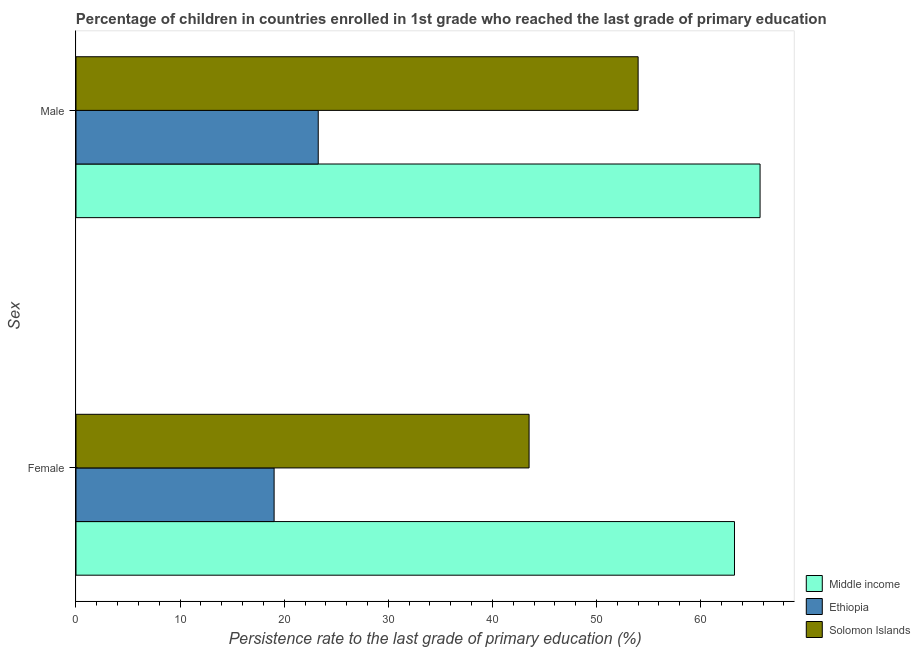How many groups of bars are there?
Give a very brief answer. 2. Are the number of bars per tick equal to the number of legend labels?
Offer a terse response. Yes. Are the number of bars on each tick of the Y-axis equal?
Your response must be concise. Yes. How many bars are there on the 2nd tick from the top?
Provide a succinct answer. 3. How many bars are there on the 2nd tick from the bottom?
Offer a very short reply. 3. What is the label of the 1st group of bars from the top?
Your answer should be very brief. Male. What is the persistence rate of male students in Solomon Islands?
Provide a short and direct response. 54. Across all countries, what is the maximum persistence rate of female students?
Your answer should be compact. 63.26. Across all countries, what is the minimum persistence rate of female students?
Your answer should be very brief. 19.03. In which country was the persistence rate of female students minimum?
Your answer should be very brief. Ethiopia. What is the total persistence rate of female students in the graph?
Give a very brief answer. 125.82. What is the difference between the persistence rate of female students in Ethiopia and that in Solomon Islands?
Ensure brevity in your answer.  -24.49. What is the difference between the persistence rate of male students in Solomon Islands and the persistence rate of female students in Ethiopia?
Give a very brief answer. 34.97. What is the average persistence rate of male students per country?
Keep it short and to the point. 47.66. What is the difference between the persistence rate of male students and persistence rate of female students in Solomon Islands?
Your answer should be compact. 10.47. What is the ratio of the persistence rate of female students in Middle income to that in Ethiopia?
Your answer should be compact. 3.32. Is the persistence rate of male students in Middle income less than that in Solomon Islands?
Make the answer very short. No. In how many countries, is the persistence rate of male students greater than the average persistence rate of male students taken over all countries?
Your answer should be compact. 2. What does the 1st bar from the top in Female represents?
Your answer should be very brief. Solomon Islands. What does the 2nd bar from the bottom in Female represents?
Offer a very short reply. Ethiopia. How many bars are there?
Provide a succinct answer. 6. How many countries are there in the graph?
Provide a short and direct response. 3. Are the values on the major ticks of X-axis written in scientific E-notation?
Make the answer very short. No. Does the graph contain any zero values?
Your answer should be very brief. No. Does the graph contain grids?
Give a very brief answer. No. Where does the legend appear in the graph?
Offer a terse response. Bottom right. How many legend labels are there?
Provide a succinct answer. 3. How are the legend labels stacked?
Your response must be concise. Vertical. What is the title of the graph?
Offer a terse response. Percentage of children in countries enrolled in 1st grade who reached the last grade of primary education. What is the label or title of the X-axis?
Make the answer very short. Persistence rate to the last grade of primary education (%). What is the label or title of the Y-axis?
Make the answer very short. Sex. What is the Persistence rate to the last grade of primary education (%) of Middle income in Female?
Make the answer very short. 63.26. What is the Persistence rate to the last grade of primary education (%) of Ethiopia in Female?
Ensure brevity in your answer.  19.03. What is the Persistence rate to the last grade of primary education (%) of Solomon Islands in Female?
Ensure brevity in your answer.  43.53. What is the Persistence rate to the last grade of primary education (%) in Middle income in Male?
Provide a short and direct response. 65.72. What is the Persistence rate to the last grade of primary education (%) of Ethiopia in Male?
Your answer should be compact. 23.27. What is the Persistence rate to the last grade of primary education (%) in Solomon Islands in Male?
Your answer should be very brief. 54. Across all Sex, what is the maximum Persistence rate to the last grade of primary education (%) of Middle income?
Your response must be concise. 65.72. Across all Sex, what is the maximum Persistence rate to the last grade of primary education (%) of Ethiopia?
Offer a terse response. 23.27. Across all Sex, what is the maximum Persistence rate to the last grade of primary education (%) in Solomon Islands?
Provide a succinct answer. 54. Across all Sex, what is the minimum Persistence rate to the last grade of primary education (%) in Middle income?
Offer a terse response. 63.26. Across all Sex, what is the minimum Persistence rate to the last grade of primary education (%) of Ethiopia?
Your answer should be compact. 19.03. Across all Sex, what is the minimum Persistence rate to the last grade of primary education (%) in Solomon Islands?
Offer a very short reply. 43.53. What is the total Persistence rate to the last grade of primary education (%) of Middle income in the graph?
Offer a very short reply. 128.98. What is the total Persistence rate to the last grade of primary education (%) of Ethiopia in the graph?
Keep it short and to the point. 42.3. What is the total Persistence rate to the last grade of primary education (%) in Solomon Islands in the graph?
Your answer should be compact. 97.53. What is the difference between the Persistence rate to the last grade of primary education (%) of Middle income in Female and that in Male?
Offer a very short reply. -2.46. What is the difference between the Persistence rate to the last grade of primary education (%) in Ethiopia in Female and that in Male?
Your answer should be compact. -4.24. What is the difference between the Persistence rate to the last grade of primary education (%) of Solomon Islands in Female and that in Male?
Your answer should be compact. -10.47. What is the difference between the Persistence rate to the last grade of primary education (%) in Middle income in Female and the Persistence rate to the last grade of primary education (%) in Ethiopia in Male?
Provide a succinct answer. 39.99. What is the difference between the Persistence rate to the last grade of primary education (%) in Middle income in Female and the Persistence rate to the last grade of primary education (%) in Solomon Islands in Male?
Ensure brevity in your answer.  9.26. What is the difference between the Persistence rate to the last grade of primary education (%) of Ethiopia in Female and the Persistence rate to the last grade of primary education (%) of Solomon Islands in Male?
Offer a terse response. -34.97. What is the average Persistence rate to the last grade of primary education (%) in Middle income per Sex?
Keep it short and to the point. 64.49. What is the average Persistence rate to the last grade of primary education (%) in Ethiopia per Sex?
Make the answer very short. 21.15. What is the average Persistence rate to the last grade of primary education (%) of Solomon Islands per Sex?
Offer a very short reply. 48.76. What is the difference between the Persistence rate to the last grade of primary education (%) of Middle income and Persistence rate to the last grade of primary education (%) of Ethiopia in Female?
Offer a terse response. 44.23. What is the difference between the Persistence rate to the last grade of primary education (%) of Middle income and Persistence rate to the last grade of primary education (%) of Solomon Islands in Female?
Your answer should be compact. 19.73. What is the difference between the Persistence rate to the last grade of primary education (%) of Ethiopia and Persistence rate to the last grade of primary education (%) of Solomon Islands in Female?
Your answer should be compact. -24.49. What is the difference between the Persistence rate to the last grade of primary education (%) of Middle income and Persistence rate to the last grade of primary education (%) of Ethiopia in Male?
Offer a very short reply. 42.44. What is the difference between the Persistence rate to the last grade of primary education (%) in Middle income and Persistence rate to the last grade of primary education (%) in Solomon Islands in Male?
Provide a succinct answer. 11.71. What is the difference between the Persistence rate to the last grade of primary education (%) in Ethiopia and Persistence rate to the last grade of primary education (%) in Solomon Islands in Male?
Your response must be concise. -30.73. What is the ratio of the Persistence rate to the last grade of primary education (%) of Middle income in Female to that in Male?
Your answer should be very brief. 0.96. What is the ratio of the Persistence rate to the last grade of primary education (%) of Ethiopia in Female to that in Male?
Your answer should be compact. 0.82. What is the ratio of the Persistence rate to the last grade of primary education (%) in Solomon Islands in Female to that in Male?
Offer a very short reply. 0.81. What is the difference between the highest and the second highest Persistence rate to the last grade of primary education (%) in Middle income?
Make the answer very short. 2.46. What is the difference between the highest and the second highest Persistence rate to the last grade of primary education (%) of Ethiopia?
Give a very brief answer. 4.24. What is the difference between the highest and the second highest Persistence rate to the last grade of primary education (%) in Solomon Islands?
Your answer should be compact. 10.47. What is the difference between the highest and the lowest Persistence rate to the last grade of primary education (%) of Middle income?
Your answer should be compact. 2.46. What is the difference between the highest and the lowest Persistence rate to the last grade of primary education (%) of Ethiopia?
Offer a terse response. 4.24. What is the difference between the highest and the lowest Persistence rate to the last grade of primary education (%) of Solomon Islands?
Your answer should be compact. 10.47. 